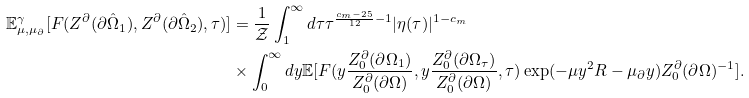Convert formula to latex. <formula><loc_0><loc_0><loc_500><loc_500>\mathbb { E } ^ { \gamma } _ { \mu , \mu _ { \partial } } [ F ( Z ^ { \partial } ( \partial \hat { \Omega } _ { 1 } ) , Z ^ { \partial } ( \partial \hat { \Omega } _ { 2 } ) , \tau ) ] & = \frac { 1 } { \mathcal { Z } } \int _ { 1 } ^ { \infty } d \tau \tau ^ { \frac { c _ { m } - 2 5 } { 1 2 } - 1 } | \eta ( \tau ) | ^ { 1 - c _ { m } } \\ & \times \int _ { 0 } ^ { \infty } d y \mathbb { E } [ F ( y \frac { Z _ { 0 } ^ { \partial } ( \partial \Omega _ { 1 } ) } { Z _ { 0 } ^ { \partial } ( \partial \Omega ) } , y \frac { Z _ { 0 } ^ { \partial } ( \partial \Omega _ { \tau } ) } { Z _ { 0 } ^ { \partial } ( \partial \Omega ) } , \tau ) \exp ( - \mu y ^ { 2 } R - \mu _ { \partial } y ) Z _ { 0 } ^ { \partial } ( \partial \Omega ) ^ { - 1 } ] .</formula> 